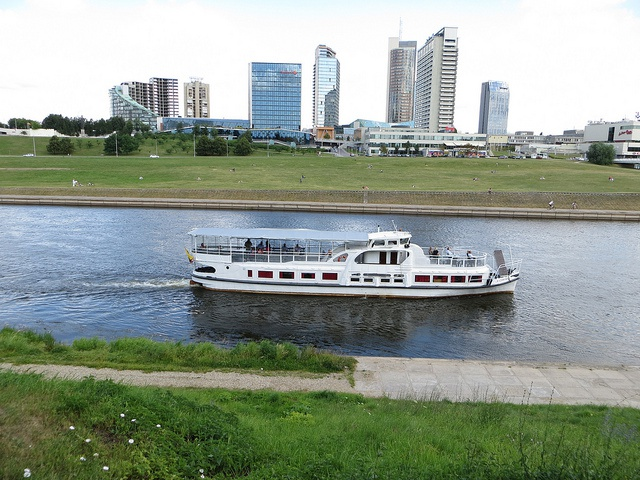Describe the objects in this image and their specific colors. I can see boat in white, lightgray, darkgray, lightblue, and gray tones, people in white, black, darkblue, and maroon tones, people in white, gray, and black tones, people in white, black, blue, and gray tones, and people in white, darkgray, lightgray, black, and gray tones in this image. 